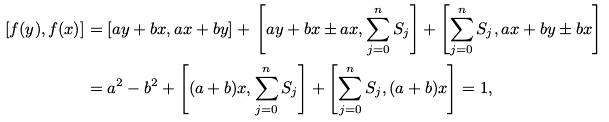<formula> <loc_0><loc_0><loc_500><loc_500>[ f ( y ) , f ( x ) ] & = [ a y + b x , a x + b y ] + \, \left [ a y + b x \pm a x , \sum _ { j = 0 } ^ { n } S _ { j } \right ] + \left [ \sum _ { j = 0 } ^ { n } S _ { j } , a x + b y \pm b x \right ] \\ & = a ^ { 2 } - b ^ { 2 } + \left [ ( a + b ) x , \sum _ { j = 0 } ^ { n } S _ { j } \right ] + \left [ \sum _ { j = 0 } ^ { n } S _ { j } , ( a + b ) x \right ] = 1 ,</formula> 